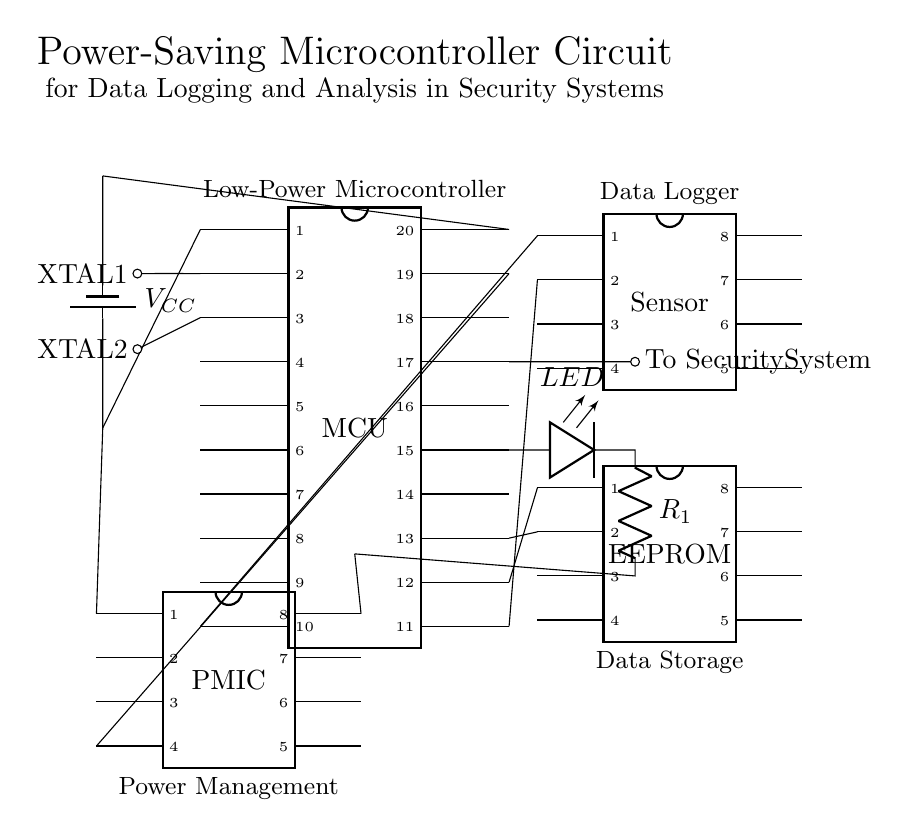What is the power supply voltage for the microcontroller? The microcontroller is powered by a battery, indicated by the label V_CC in the diagram. The symbol shows a typical voltage associated with microcontrollers, which is often five volts.
Answer: 5 volts What components are used for data logging? The data logging function is provided by the ‘Sensor’ component, which is connected to pins 10 and 11 of the microcontroller, indicating it is meant to gather data that will be processed.
Answer: Sensor How many pins does the microcontroller have? The microcontroller (MCU) is depicted with a total of 20 pins as noted in the diagram style for dipchips. This includes various pins for power, data input/output, and connections to other components.
Answer: 20 pins What is the role of the power management IC? The power management IC (PMIC) regulates the power supply to the circuit. It connects to the power supply and also interfaces with both the microcontroller and the LED, managing voltage and current levels to ensure efficient operation of the low-power circuit.
Answer: Power regulation Which component is responsible for data storage? The EEPROM (Electrically Erasable Programmable Read-Only Memory) is responsible for data storage in this circuit. It connects to the microcontroller and allows for persistent data storage after the microcontroller is powered down.
Answer: EEPROM What type of LED is used in the circuit? The LED used in this circuit is a low-power LED, as indicated by its drawing and positioning within the low-power design context. It connects to the microcontroller for visual indication of status without drawing significant current.
Answer: Low-power LED How does the circuit achieve low power consumption? The circuit achieves low power consumption by utilizing a power management IC, which regulates voltage levels efficiently, along with selecting low-power components like the microcontroller and LED. Proper design and component selection help minimize overall energy usage.
Answer: Low power design 